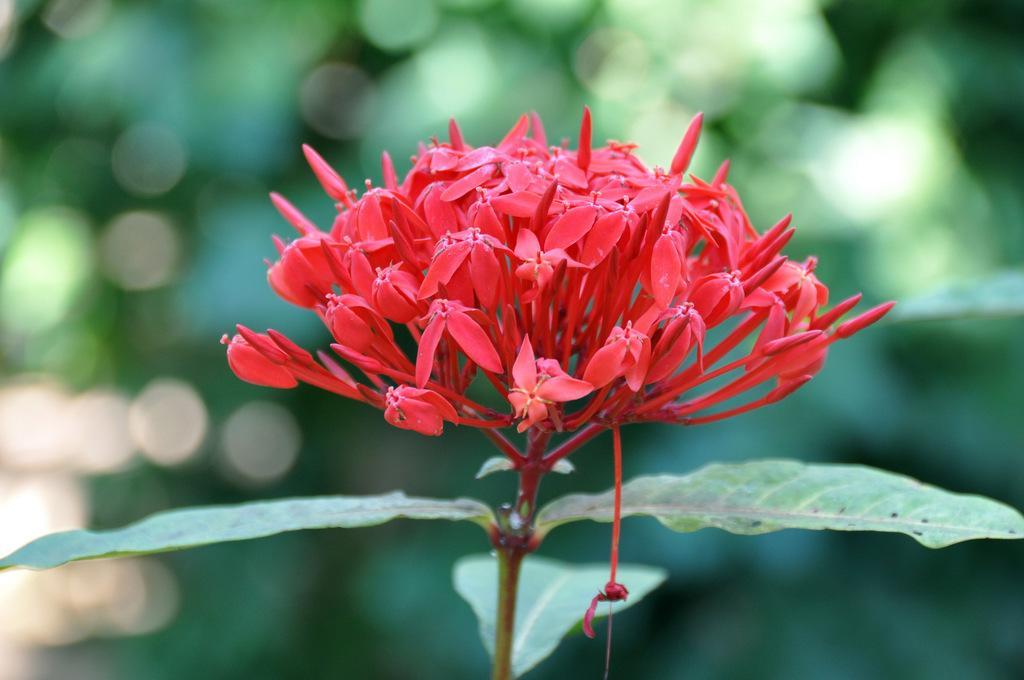Please provide a concise description of this image. In the image we can see tiny red flowers, here we can see the stem and the leaves and the background is blurred. 